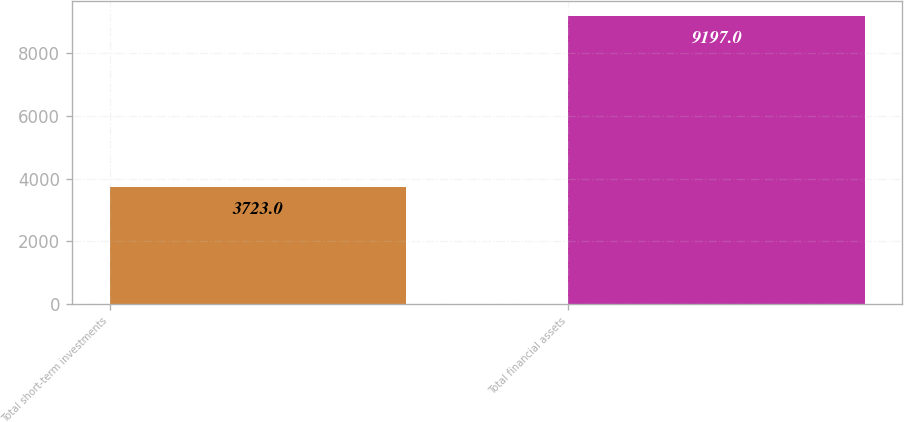<chart> <loc_0><loc_0><loc_500><loc_500><bar_chart><fcel>Total short-term investments<fcel>Total financial assets<nl><fcel>3723<fcel>9197<nl></chart> 